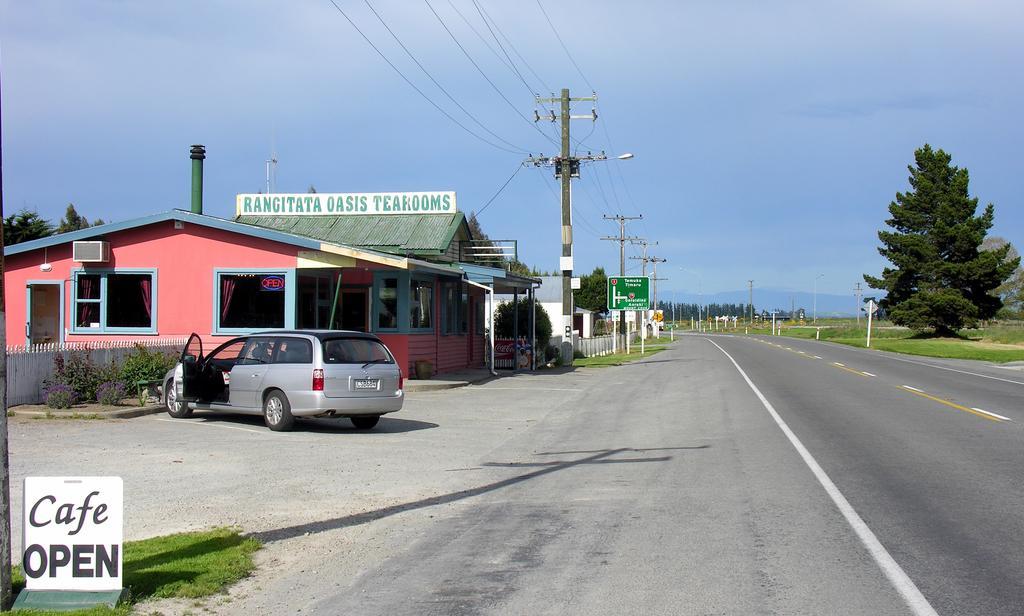Can you describe this image briefly? Here we can see a car. There are boards, poles, trees, grass, fence, plants, and houses. There is a road. In the background we can see sky. 